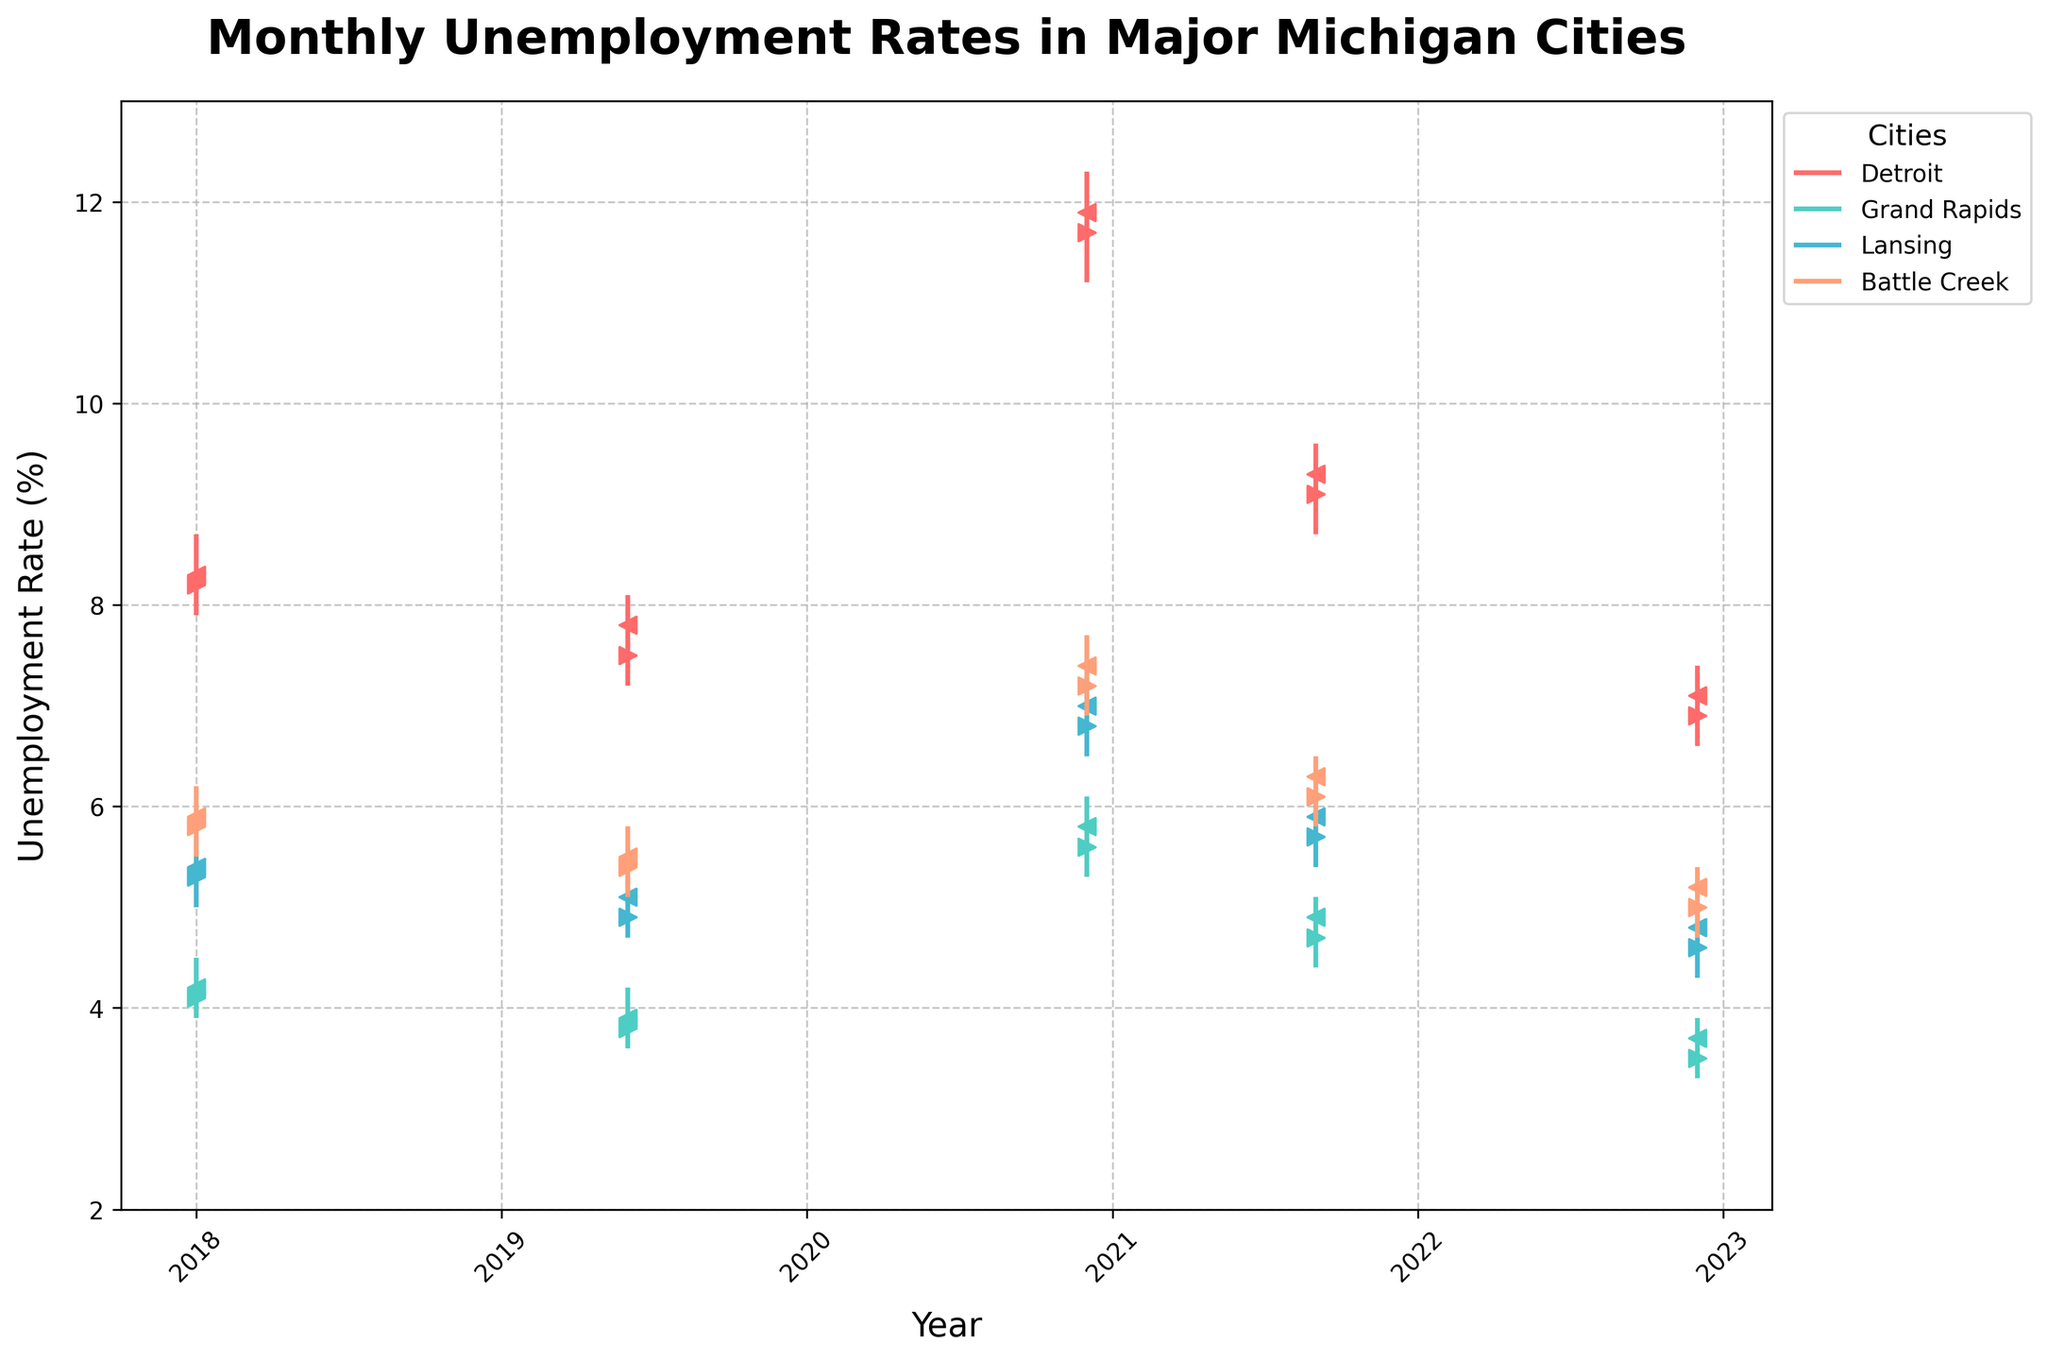What is the title of the figure? The title is written in bold at the top of the figure. It reads "Monthly Unemployment Rates in Major Michigan Cities".
Answer: Monthly Unemployment Rates in Major Michigan Cities Which city has the highest closing unemployment rate in December 2020? We can see "Close" values represented by the left-facing arrows for each city. In December 2020, Detroit has the highest close value at 11.9%.
Answer: Detroit What is the range of unemployment rates for Lansing in January 2018? The range can be determined by the difference between the high and low values in January 2018 for Lansing. The high is 5.7 and the low is 5.0, so the range is 5.7 - 5.0 = 0.7.
Answer: 0.7 How did Battle Creek's closing unemployment rate change from January 2018 to December 2022? The closing rate in January 2018 for Battle Creek is 5.9, and in December 2022, it is 5.2. The change is 5.2 - 5.9 = -0.7, indicating a decrease.
Answer: Decreased by 0.7 What is the average closing unemployment rate of Grand Rapids for the given dates? The closing rates for Grand Rapids are 4.2 (Jan 2018), 3.9 (Jun 2019), 5.8 (Dec 2020), 4.9 (Sep 2021), and 3.7 (Dec 2022). Summing these up: 4.2 + 3.9 + 5.8 + 4.9 + 3.7 = 22.5. The average is 22.5 / 5 = 4.5.
Answer: 4.5 Between Detroit and Grand Rapids, which city had the higher unemployment rate variability in December 2020? Unemployment rate variability can be calculated by the range (High - Low) for each city. For Detroit: 12.3 - 11.2 = 1.1, for Grand Rapids: 6.1 - 5.3 = 0.8. Detroit had higher variability.
Answer: Detroit In which month was Battle Creek's unemployment rate highest and what was the value? To find the highest rate for Battle Creek, we look at the High values. The highest rate is 7.7 in December 2020.
Answer: December 2020, 7.7 Which city consistently had the lowest unemployment rates in the given periods? By reviewing the Close values, Grand Rapids consistently shows the lowest rates across the period, especially prominently lower in all shown data points.
Answer: Grand Rapids 